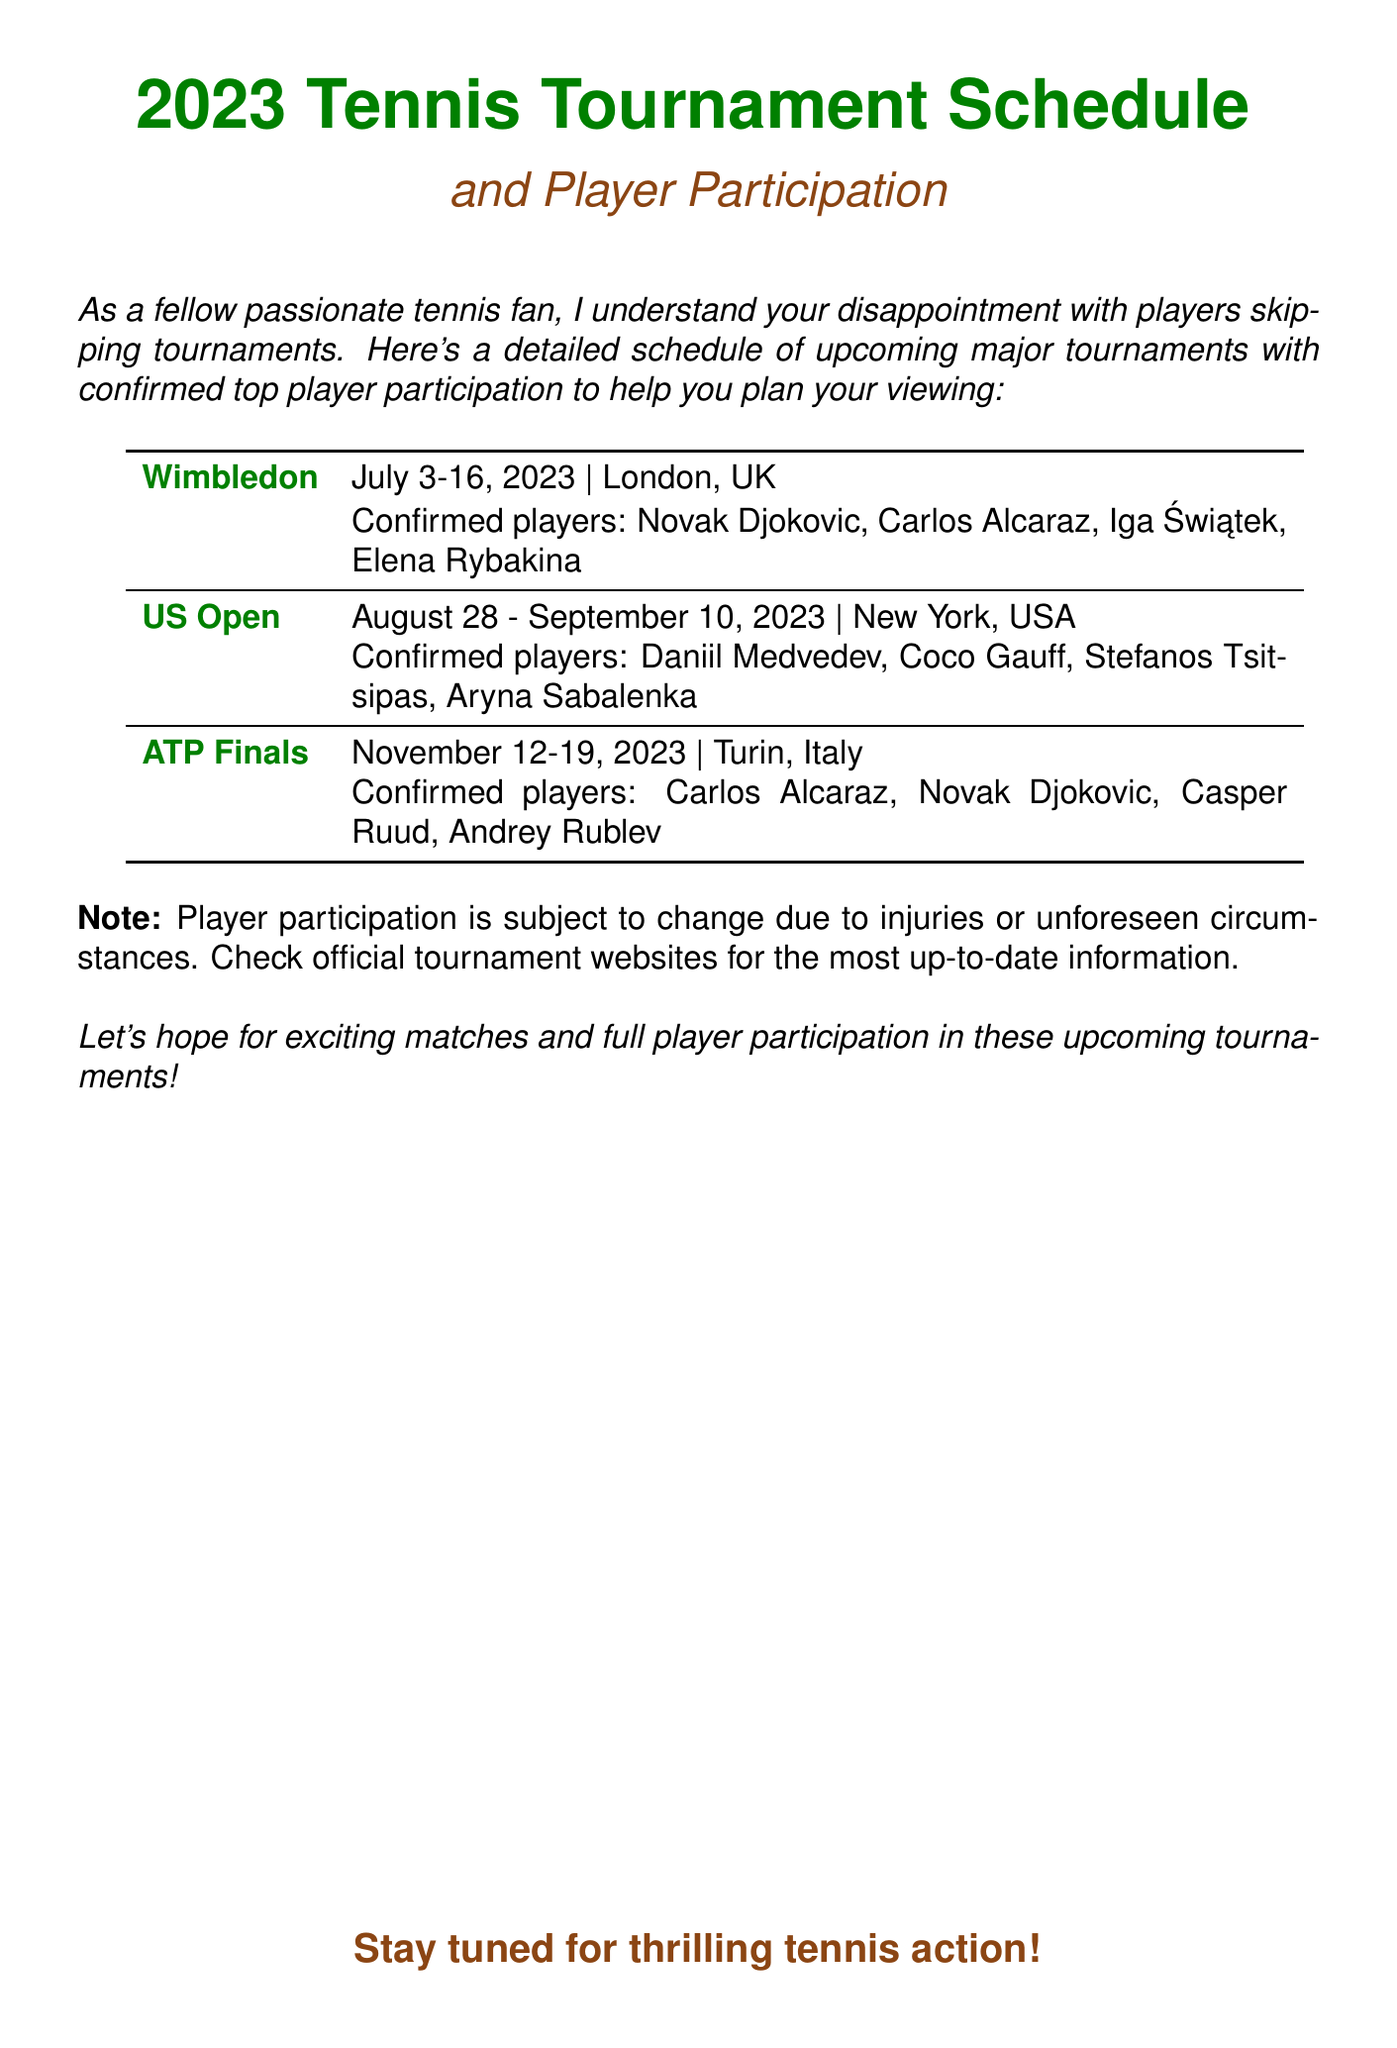What are the dates for Wimbledon? The dates for Wimbledon are specified in the document as July 3-16, 2023.
Answer: July 3-16, 2023 Which players are confirmed for the US Open? The document lists the confirmed players for the US Open, which include Daniil Medvedev, Coco Gauff, Stefanos Tsitsipas, and Aryna Sabalenka.
Answer: Daniil Medvedev, Coco Gauff, Stefanos Tsitsipas, Aryna Sabalenka Where is the ATP Finals taking place? The location of the ATP Finals is indicated in the document as Turin, Italy.
Answer: Turin, Italy How many confirmed players are listed for the Wimbledon tournament? The document names four confirmed players for Wimbledon: Novak Djokovic, Carlos Alcaraz, Iga Świątek, and Elena Rybakina.
Answer: 4 Which tournament occurs last in the schedule? The last tournament in the given schedule is the ATP Finals, which takes place in November 2023.
Answer: ATP Finals What is the significance of player participation? The document notes that player participation is subject to change due to injuries or unforeseen circumstances.
Answer: Subject to change Which tournament features Carlos Alcaraz? The document shows that Carlos Alcaraz is confirmed for Wimbledon, US Open, and ATP Finals.
Answer: Wimbledon, US Open, ATP Finals When does the US Open start? According to the document, the US Open starts on August 28, 2023.
Answer: August 28, 2023 What colors are used for headings in the document? The document utilizes tennis green for the main headings and tennis brown for the subheadings.
Answer: Tennis green, tennis brown 